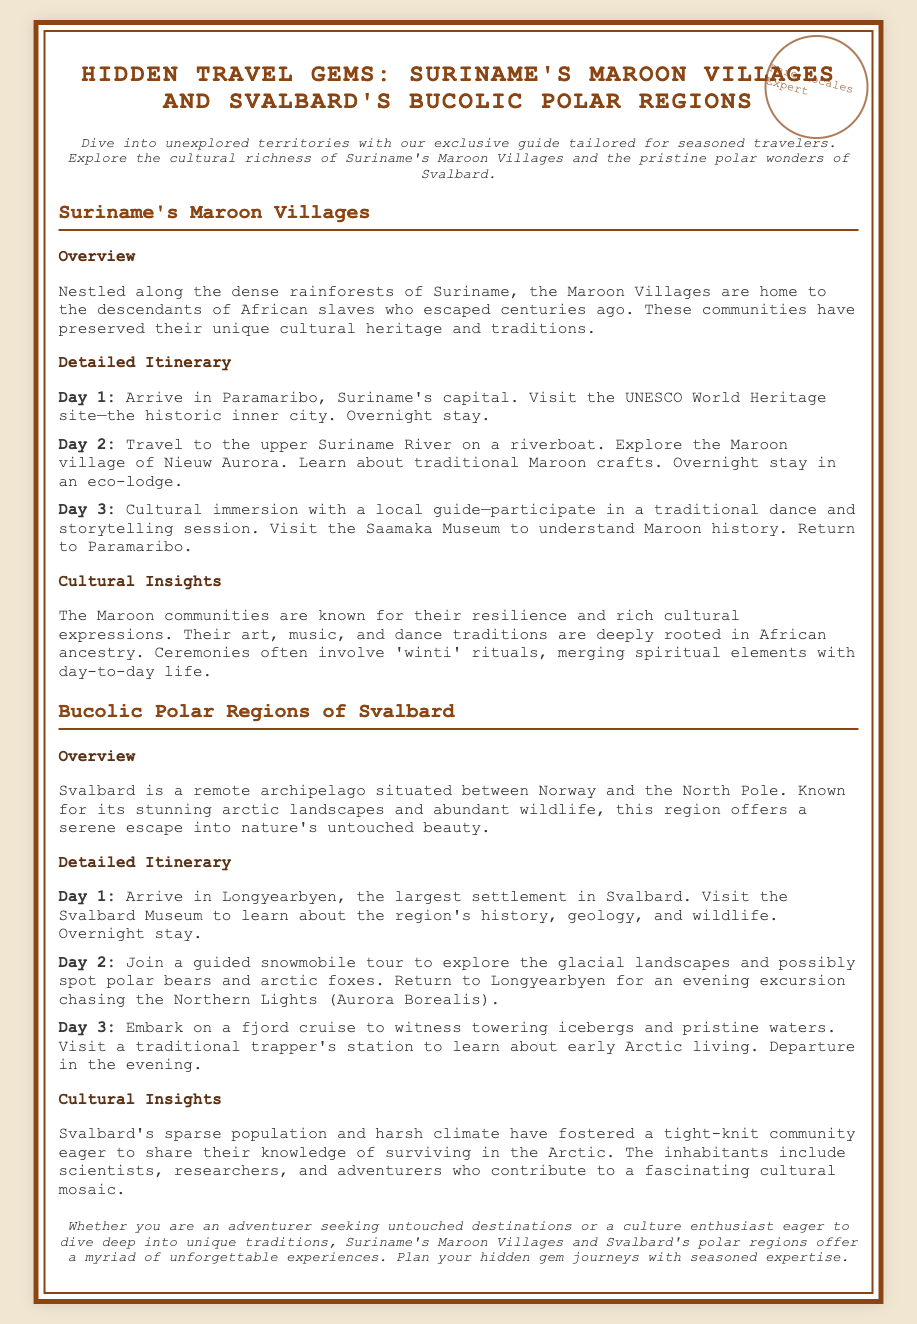What is the title of the Playbill? The title is clearly stated at the top of the document, highlighting the main focus of the content.
Answer: Hidden Travel Gems: Suriname's Maroon Villages and Svalbard's Bucolic Polar Regions What is the capital of Suriname? The capital is mentioned in the itinerary for Day 1 under Suriname's section.
Answer: Paramaribo How many days is the itinerary for Suriname's Maroon Villages? The detailed itinerary for Suriname includes three specific days of activities.
Answer: 3 What type of traditional session do visitors participate in on Day 3 in Suriname? The cultural immersion activity involves a specific type of cultural expression highlighted in the itinerary.
Answer: Traditional dance and storytelling session What is a cultural element emphasized in Svalbard? The document provides a brief overview of the inhabitants’ focus in the polar regions.
Answer: Surviving in the Arctic How many days is the itinerary for Svalbard? The structured travel plan for Svalbard consists of three specific days outlined in the document.
Answer: 3 What is the primary wildlife attraction during the snowmobile tour in Svalbard? The wildlife that can be spotted during the tour is explicitly mentioned in the itinerary for Day 2.
Answer: Polar bears What is the overall focus of the Playbill? The introduction clearly describes the main purpose and themes of the guide in the beginning section.
Answer: Hidden travel gems What type of accommodation is suggested for the Maroon village visit? The type of lodging during the Maroon village experience is explicitly mentioned in the itinerary on Day 2.
Answer: Eco-lodge 